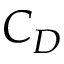Convert formula to latex. <formula><loc_0><loc_0><loc_500><loc_500>C _ { D }</formula> 